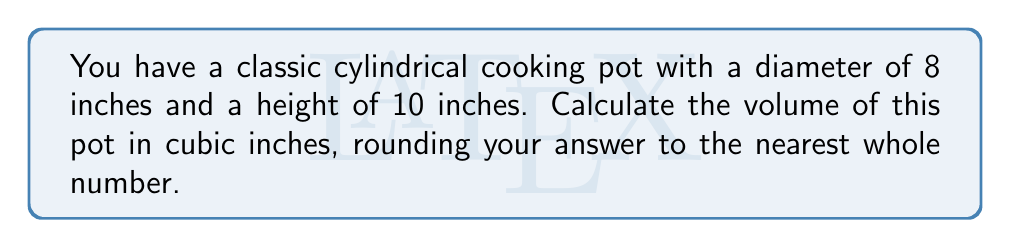Show me your answer to this math problem. Let's approach this step-by-step using the formula for the volume of a cylinder:

1) The formula for the volume of a cylinder is:
   $$V = \pi r^2 h$$
   where $V$ is volume, $r$ is the radius of the base, and $h$ is the height.

2) We're given the diameter (8 inches) and height (10 inches). We need to find the radius:
   $$r = \frac{\text{diameter}}{2} = \frac{8}{2} = 4\text{ inches}$$

3) Now we can plug our values into the formula:
   $$V = \pi (4\text{ in})^2 (10\text{ in})$$

4) Simplify:
   $$V = \pi (16\text{ in}^2) (10\text{ in}) = 160\pi\text{ in}^3$$

5) Calculate and round to the nearest whole number:
   $$V \approx 160 \times 3.14159 \approx 502.65\text{ in}^3 \approx 503\text{ in}^3$$

Thus, the volume of the cooking pot is approximately 503 cubic inches.
Answer: 503 in³ 